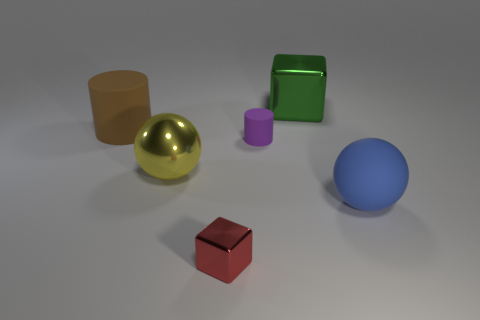Add 3 big purple metal things. How many objects exist? 9 Add 1 large gray rubber cubes. How many large gray rubber cubes exist? 1 Subtract 1 red cubes. How many objects are left? 5 Subtract all big shiny things. Subtract all yellow spheres. How many objects are left? 3 Add 6 metallic balls. How many metallic balls are left? 7 